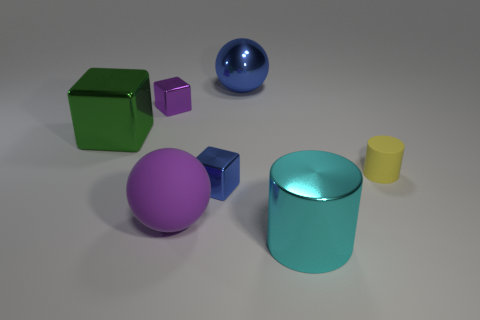Can you explain what the different shapes in the image represent? Certainly! The image features a collection of geometric shapes that could represent different concepts depending on the context. They might be used to demonstrate spatial relationships or to teach concepts of geometry. The variety of shapes and colors also makes them ideal for visual contrast and composition studies in art and design education. 